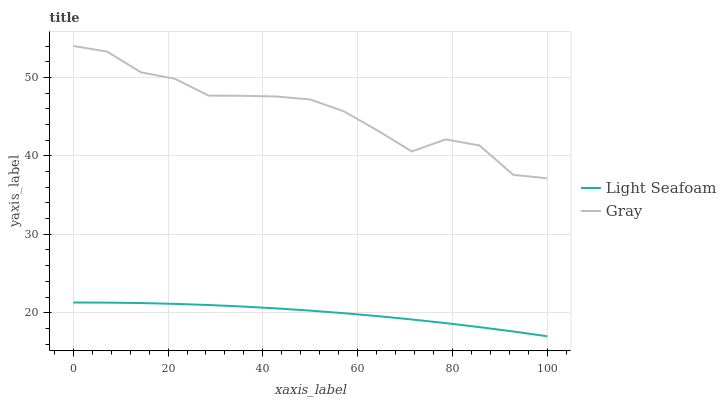Does Light Seafoam have the minimum area under the curve?
Answer yes or no. Yes. Does Gray have the maximum area under the curve?
Answer yes or no. Yes. Does Light Seafoam have the maximum area under the curve?
Answer yes or no. No. Is Light Seafoam the smoothest?
Answer yes or no. Yes. Is Gray the roughest?
Answer yes or no. Yes. Is Light Seafoam the roughest?
Answer yes or no. No. Does Light Seafoam have the lowest value?
Answer yes or no. Yes. Does Gray have the highest value?
Answer yes or no. Yes. Does Light Seafoam have the highest value?
Answer yes or no. No. Is Light Seafoam less than Gray?
Answer yes or no. Yes. Is Gray greater than Light Seafoam?
Answer yes or no. Yes. Does Light Seafoam intersect Gray?
Answer yes or no. No. 